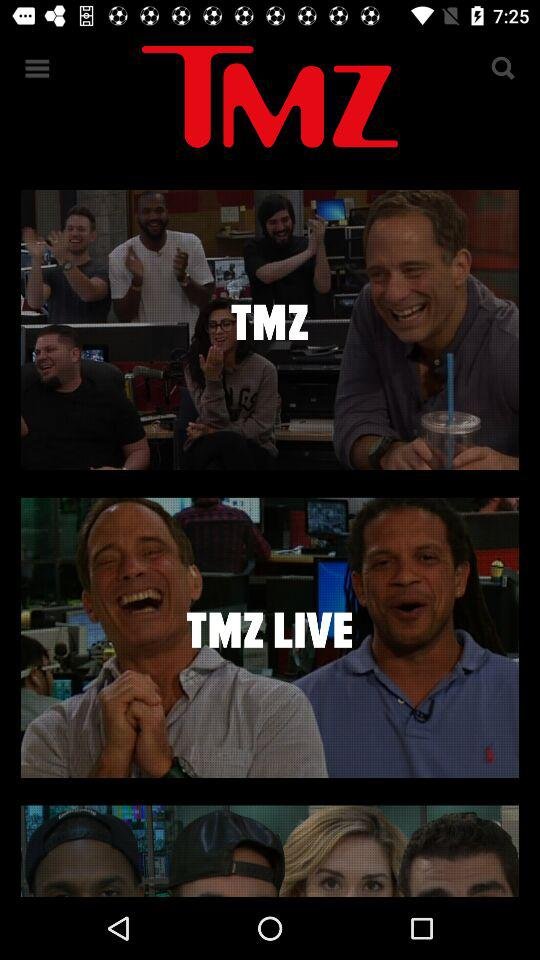Which shows are available on "TMZ LIVE"?
When the provided information is insufficient, respond with <no answer>. <no answer> 